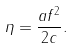Convert formula to latex. <formula><loc_0><loc_0><loc_500><loc_500>\eta = \frac { a f ^ { 2 } } { 2 c } .</formula> 